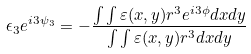<formula> <loc_0><loc_0><loc_500><loc_500>\epsilon _ { 3 } e ^ { i 3 \psi _ { 3 } } = - \frac { \int \int \varepsilon ( x , y ) r ^ { 3 } e ^ { i 3 \phi } d x d y } { \int \int \varepsilon ( x , y ) r ^ { 3 } d x d y }</formula> 